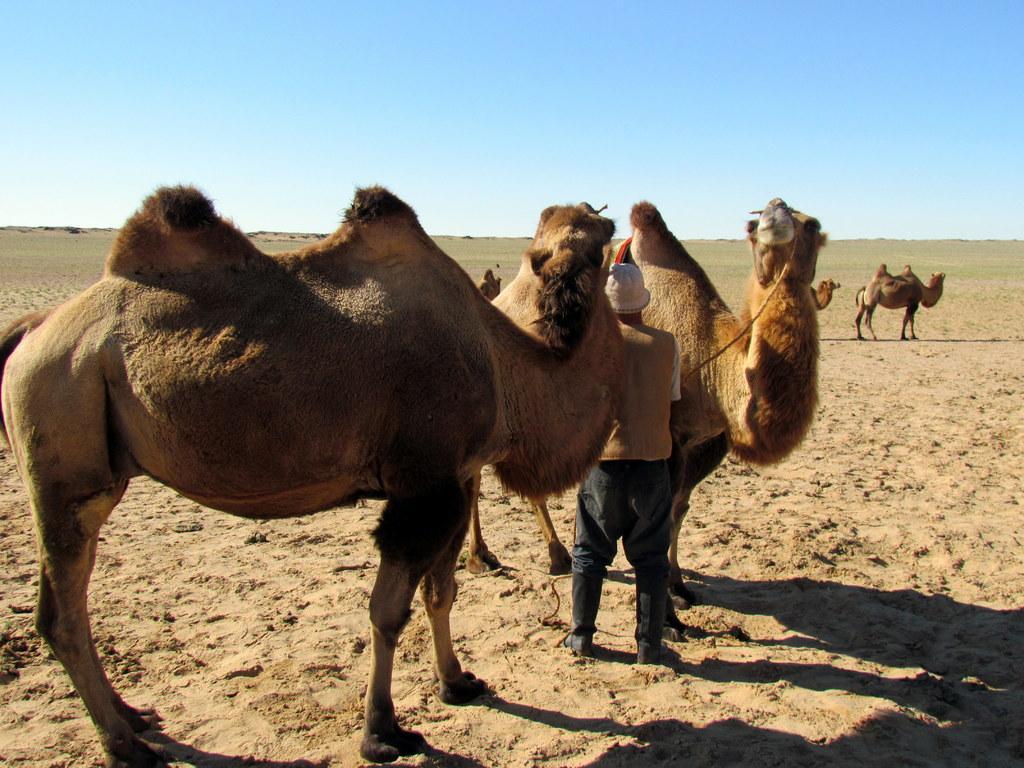In one or two sentences, can you explain what this image depicts? In the image there are group of camels in the desert and some people are standing beside the camels. The climate is very sunny. 